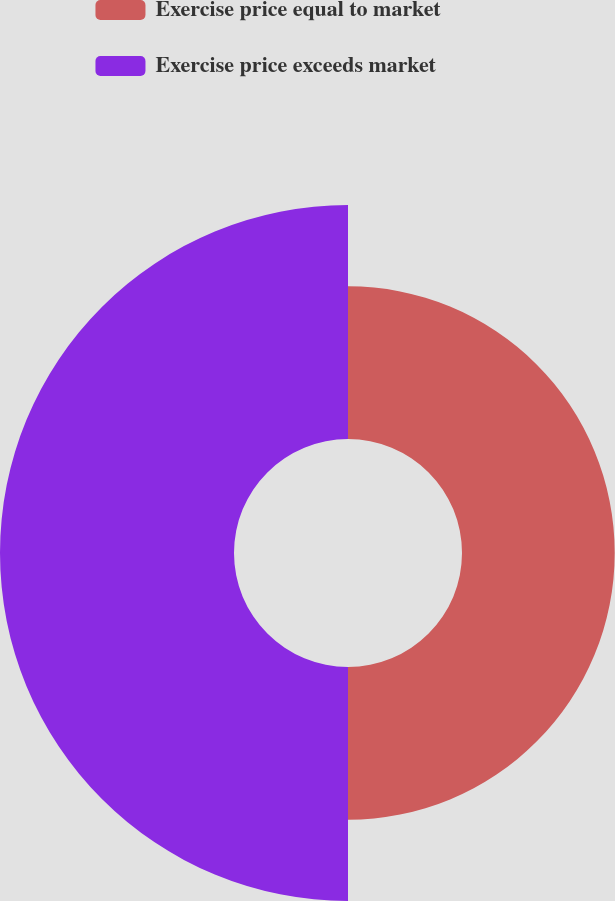Convert chart to OTSL. <chart><loc_0><loc_0><loc_500><loc_500><pie_chart><fcel>Exercise price equal to market<fcel>Exercise price exceeds market<nl><fcel>39.49%<fcel>60.51%<nl></chart> 